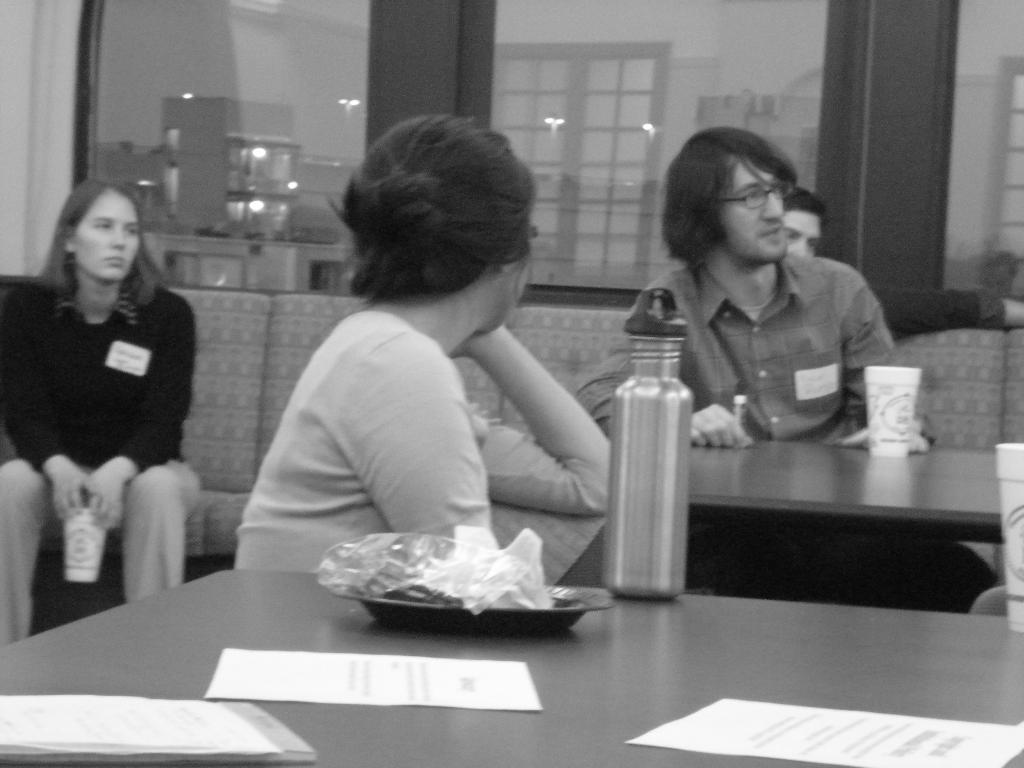How many people are in the image? There is a group of people in the image. What are the people doing in the image? The people are sitting on a couch. Where is the couch located in relation to the table? The couch is in front of a table. What can be found on the table in the image? There are objects on the table. What type of dinner is being served on the table in the image? There is no dinner present in the image; it only shows a group of people sitting on a couch and objects on a table. Can you tell me how many people are swimming in the image? There is no swimming activity depicted in the image; it features a group of people sitting on a couch. 